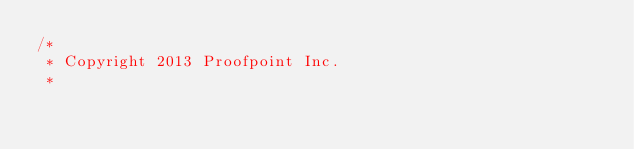Convert code to text. <code><loc_0><loc_0><loc_500><loc_500><_Java_>/*
 * Copyright 2013 Proofpoint Inc.
 *</code> 